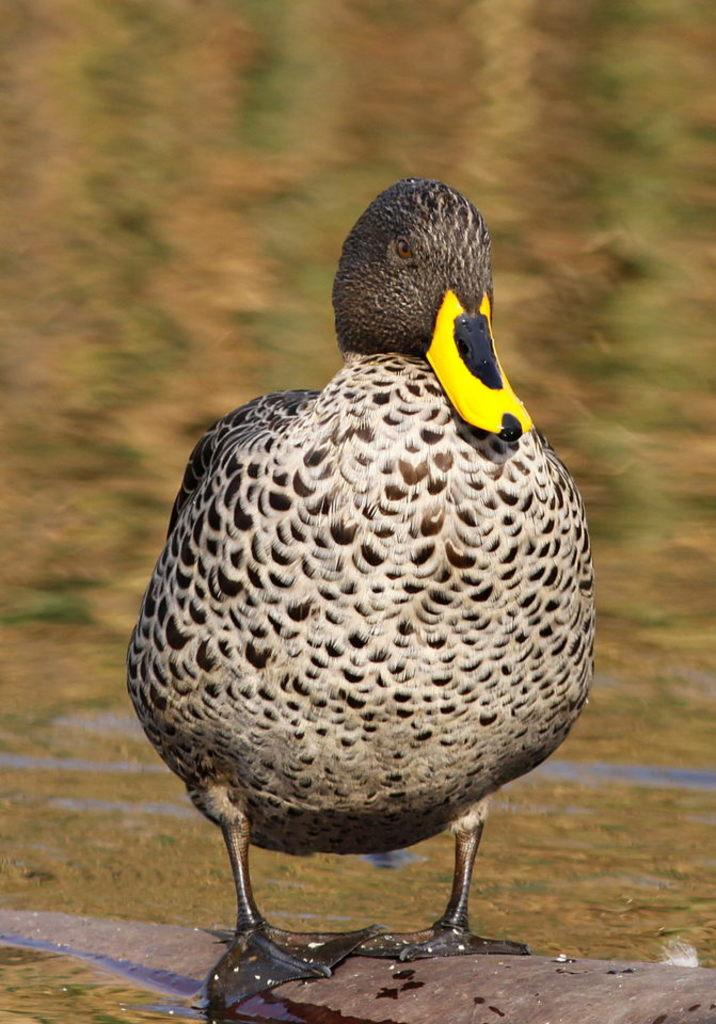What animal is present in the image? There is a duck in the image. Where is the duck located in relation to the rest of the scene? The duck is standing in the front. What colors can be seen on the duck? The duck's color is white and black. How would you describe the quality of the background in the image? The image is blurry in the background. What type of test is the duck taking in the image? There is no indication in the image that the duck is taking a test, as ducks do not take tests. 